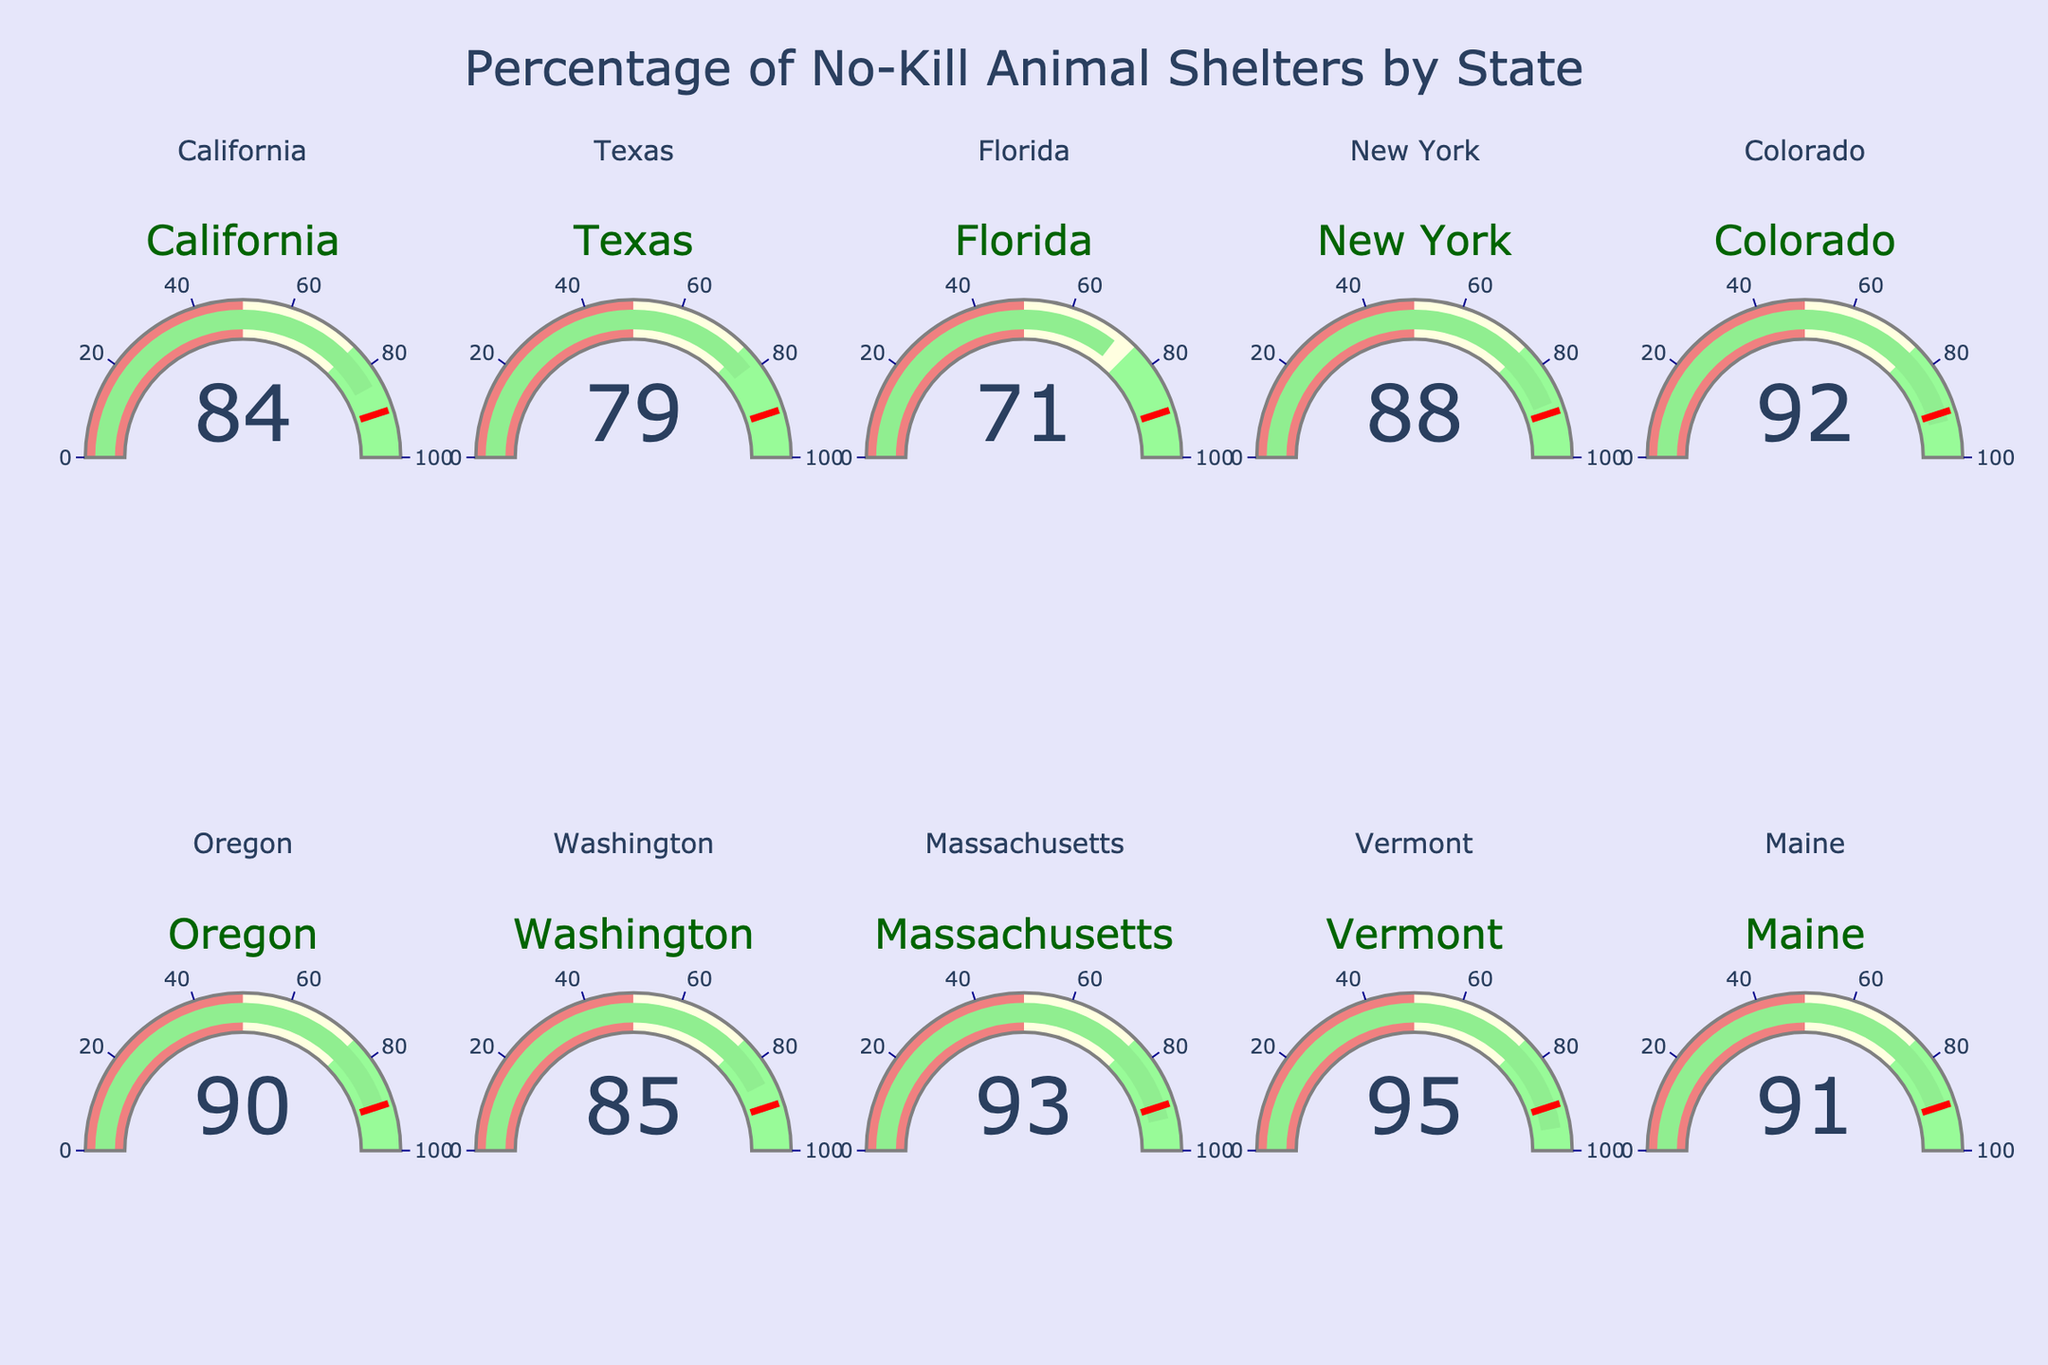Which state has the highest percentage of no-kill animal shelters? The gauge chart shows that Vermont has the highest percentage with 95%.
Answer: Vermont Which state has the lowest percentage of no-kill animal shelters? The gauge chart indicates that Florida has the lowest percentage with 71%.
Answer: Florida What is the average percentage of no-kill animal shelters across all shown states? To find the average, sum the percentages and then divide by the number of states. The sum is 84+79+71+88+92+90+85+93+95+91 = 868. The number of states is 10. Average = 868 / 10 = 86.8
Answer: 86.8 How many states have a no-kill percentage greater than 90%? The states exceeding 90% are Colorado, Oregon, Massachusetts, Vermont, and Maine, totaling 5 states.
Answer: 5 Which states have a no-kill percentage exactly equal to 90%? The gauge chart shows that Oregon has a no-kill percentage exactly equal to 90%.
Answer: Oregon What is the difference in the no-kill percentage between California and Texas? California has 84%, and Texas has 79%. The difference is 84 - 79 = 5.
Answer: 5 Are there any states with a no-kill percentage in the range of 80% to 90%, inclusive? The states in this range are California (84%), Texas (79%), New York (88%), Oregon (90%), and Washington (85%).
Answer: Yes Which state is closer to the threshold value of 90%, Maine or Colorado? Maine has 91%, and Colorado has 92%. The difference from 90% is 1% for Maine and 2% for Colorado, so Maine is closer.
Answer: Maine How many states have a no-kill percentage above the threshold value of 90%? The states with values above 90% are Colorado, Massachusetts, Vermont, and Maine, totaling 4 states.
Answer: 4 Is there any state with a no-kill percentage below 75%? The gauge chart shows that Florida is the only state below 75% with 71%.
Answer: Yes 